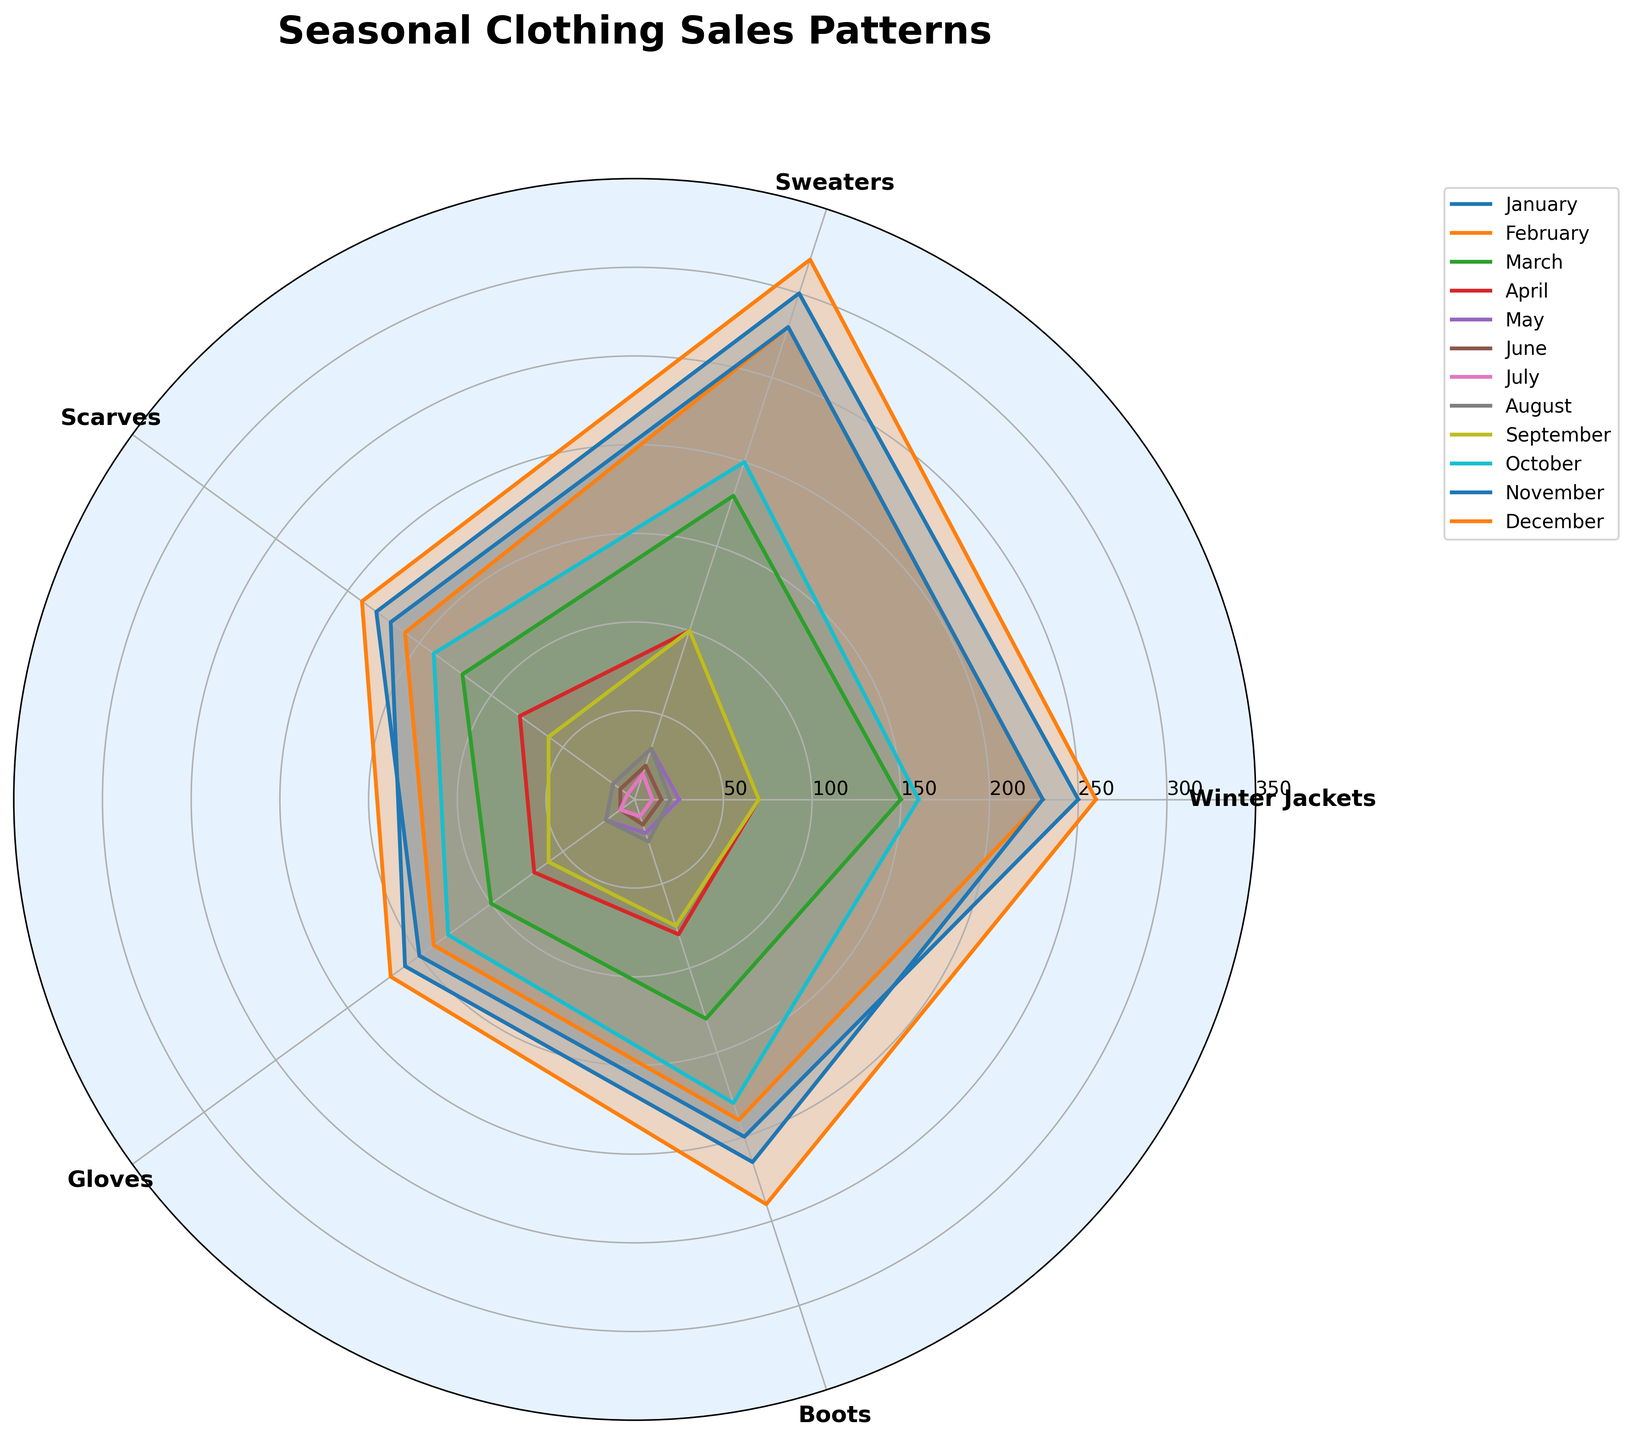What is the title of the chart? Look at the top of the chart for the large, bold text.
Answer: Seasonal Clothing Sales Patterns Which category of attire has the highest sales in January? Look at the values in January by finding the January line and seeing which category extends the furthest.
Answer: Sweaters Which month shows the lowest sales for gloves? By checking each line for the gloves category, identify the month with the smallest radius.
Answer: July How do the sales of winter jackets in November compare to those in February? Identify the points for November and February on the winter jacket line, and compare the distances from the center. November's point is further away.
Answer: Higher in November Which winter-related category sees the smallest sales increase from February to December? Compare the distances between February and December points for each winter category (Winter Jackets, Sweaters, Scarves, Gloves, Boots) and identify the smallest gap.
Answer: Gloves What is the average number of boots sold in March, April, and May? Add the sales of boots in March (130), April (80), and May (20) and then divide by 3. (130 + 80 + 20) / 3 = 230 / 3 ≈ 76.67
Answer: 76.67 In which month are scarf sales higher: October or April? Compare the distances for scarf sales in October and April by observing the length from the center to the scarf points in both months. October's point is further.
Answer: October What is the sum of sweater sales in January, February, and December? Add the sales of sweaters in January (300), February (280), and December (320). 300 + 280 + 320 = 900
Answer: 900 During which month were winter jacket sales the lowest? Identify the month with the shortest radius for the winter jacket category.
Answer: July By how much do sales of sweaters in September differ from sales in November? Find the values for sweaters in September (100) and November (280) and compute the difference. 280 - 100 = 180
Answer: 180 